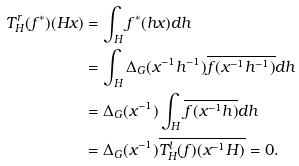<formula> <loc_0><loc_0><loc_500><loc_500>T _ { H } ^ { r } ( f ^ { * } ) ( H x ) & = \int _ { H } f ^ { * } ( h x ) d h \\ & = \int _ { H } \Delta _ { G } ( x ^ { - 1 } h ^ { - 1 } ) \overline { f ( x ^ { - 1 } h ^ { - 1 } ) } d h \\ & = \Delta _ { G } ( x ^ { - 1 } ) \int _ { H } \overline { f ( x ^ { - 1 } h ) } d h \\ & = \Delta _ { G } ( x ^ { - 1 } ) \overline { T _ { H } ^ { l } ( f ) ( x ^ { - 1 } H ) } = 0 .</formula> 